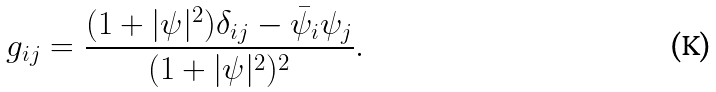Convert formula to latex. <formula><loc_0><loc_0><loc_500><loc_500>g _ { i j } = \frac { ( 1 + | \psi | ^ { 2 } ) \delta _ { i j } - \bar { \psi } _ { i } \psi _ { j } } { ( 1 + | \psi | ^ { 2 } ) ^ { 2 } } .</formula> 